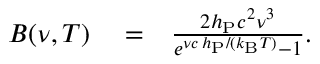<formula> <loc_0><loc_0><loc_500><loc_500>\begin{array} { r l r } { B ( \nu , T ) } & = } & { \frac { 2 h _ { P } c ^ { 2 } \nu ^ { 3 } } { e ^ { \nu c \, h _ { P } / ( k _ { B } T ) } - 1 } . } \end{array}</formula> 